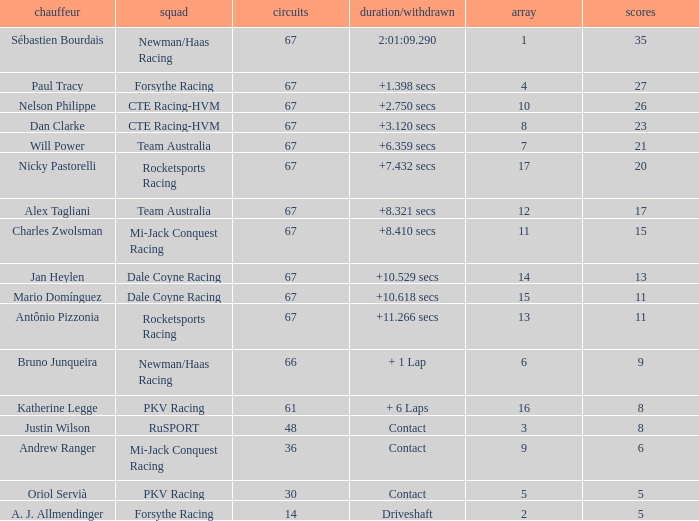What was time/retired with less than 67 laps and 6 points? Contact. 